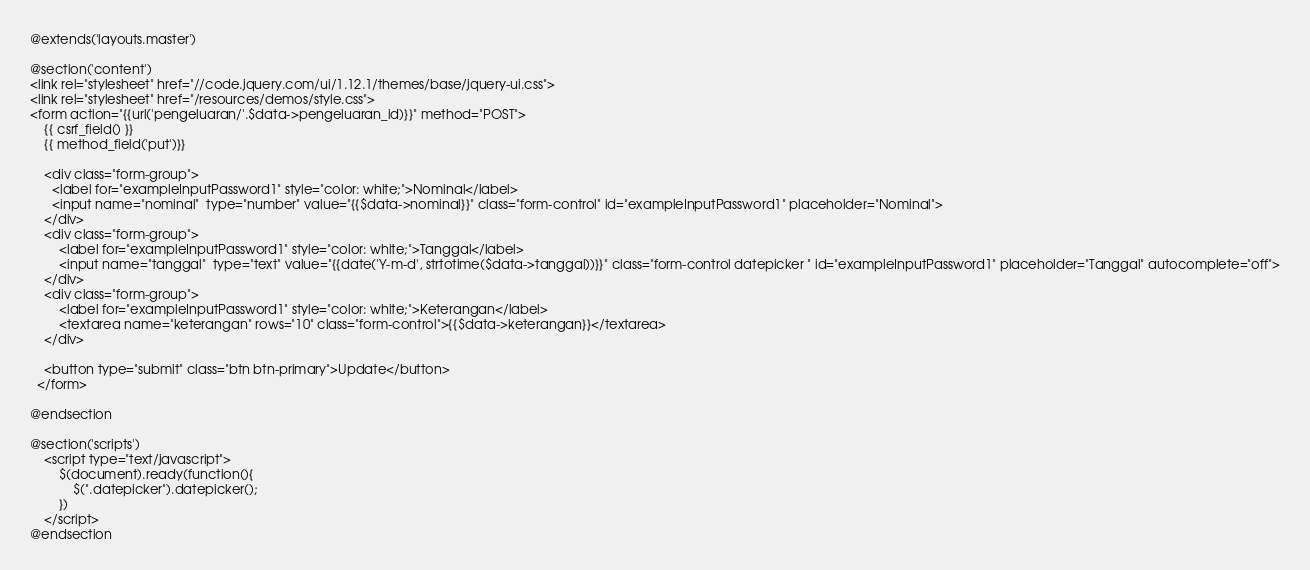Convert code to text. <code><loc_0><loc_0><loc_500><loc_500><_PHP_>@extends('layouts.master')

@section('content')
<link rel="stylesheet" href="//code.jquery.com/ui/1.12.1/themes/base/jquery-ui.css">
<link rel="stylesheet" href="/resources/demos/style.css">
<form action="{{url('pengeluaran/'.$data->pengeluaran_id)}}" method="POST">
    {{ csrf_field() }}
    {{ method_field('put')}}
    
    <div class="form-group">
      <label for="exampleInputPassword1" style="color: white;">Nominal</label>
      <input name="nominal"  type="number" value="{{$data->nominal}}" class="form-control" id="exampleInputPassword1" placeholder="Nominal">
    </div>
    <div class="form-group">
        <label for="exampleInputPassword1" style="color: white;">Tanggal</label>
        <input name="tanggal"  type="text" value="{{date('Y-m-d', strtotime($data->tanggal))}}" class="form-control datepicker " id="exampleInputPassword1" placeholder="Tanggal" autocomplete="off">
    </div>
    <div class="form-group">
        <label for="exampleInputPassword1" style="color: white;">Keterangan</label>
        <textarea name="keterangan" rows="10" class="form-control">{{$data->keterangan}}</textarea>
    </div>
    
    <button type="submit" class="btn btn-primary">Update</button>
  </form>
    
@endsection

@section('scripts')
    <script type="text/javascript">
        $(document).ready(function(){
            $(".datepicker").datepicker();
        })
    </script>
@endsection</code> 